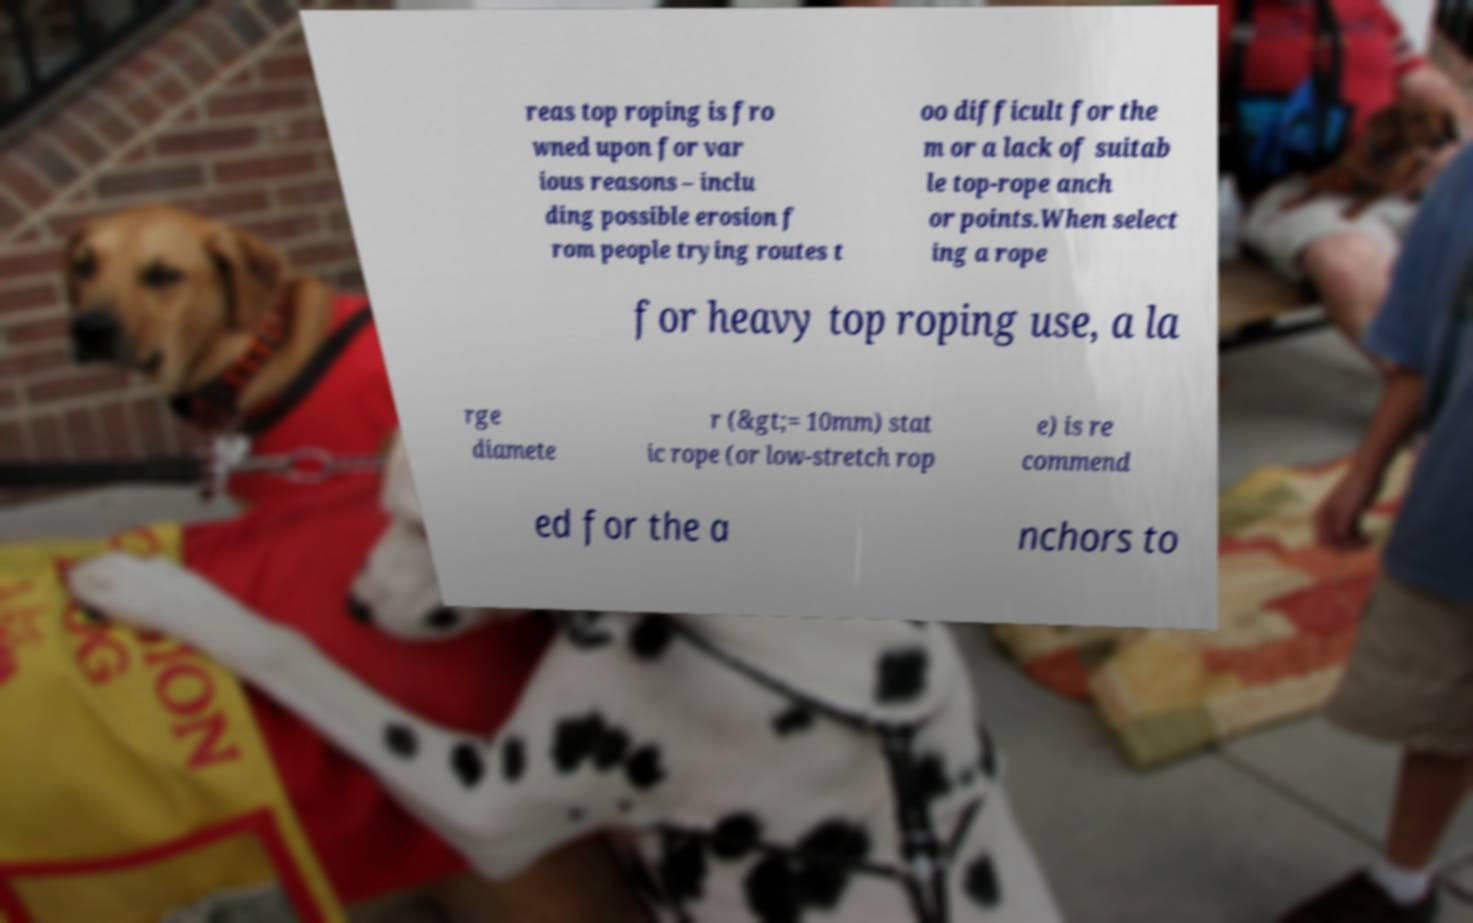There's text embedded in this image that I need extracted. Can you transcribe it verbatim? reas top roping is fro wned upon for var ious reasons – inclu ding possible erosion f rom people trying routes t oo difficult for the m or a lack of suitab le top-rope anch or points.When select ing a rope for heavy top roping use, a la rge diamete r (&gt;= 10mm) stat ic rope (or low-stretch rop e) is re commend ed for the a nchors to 